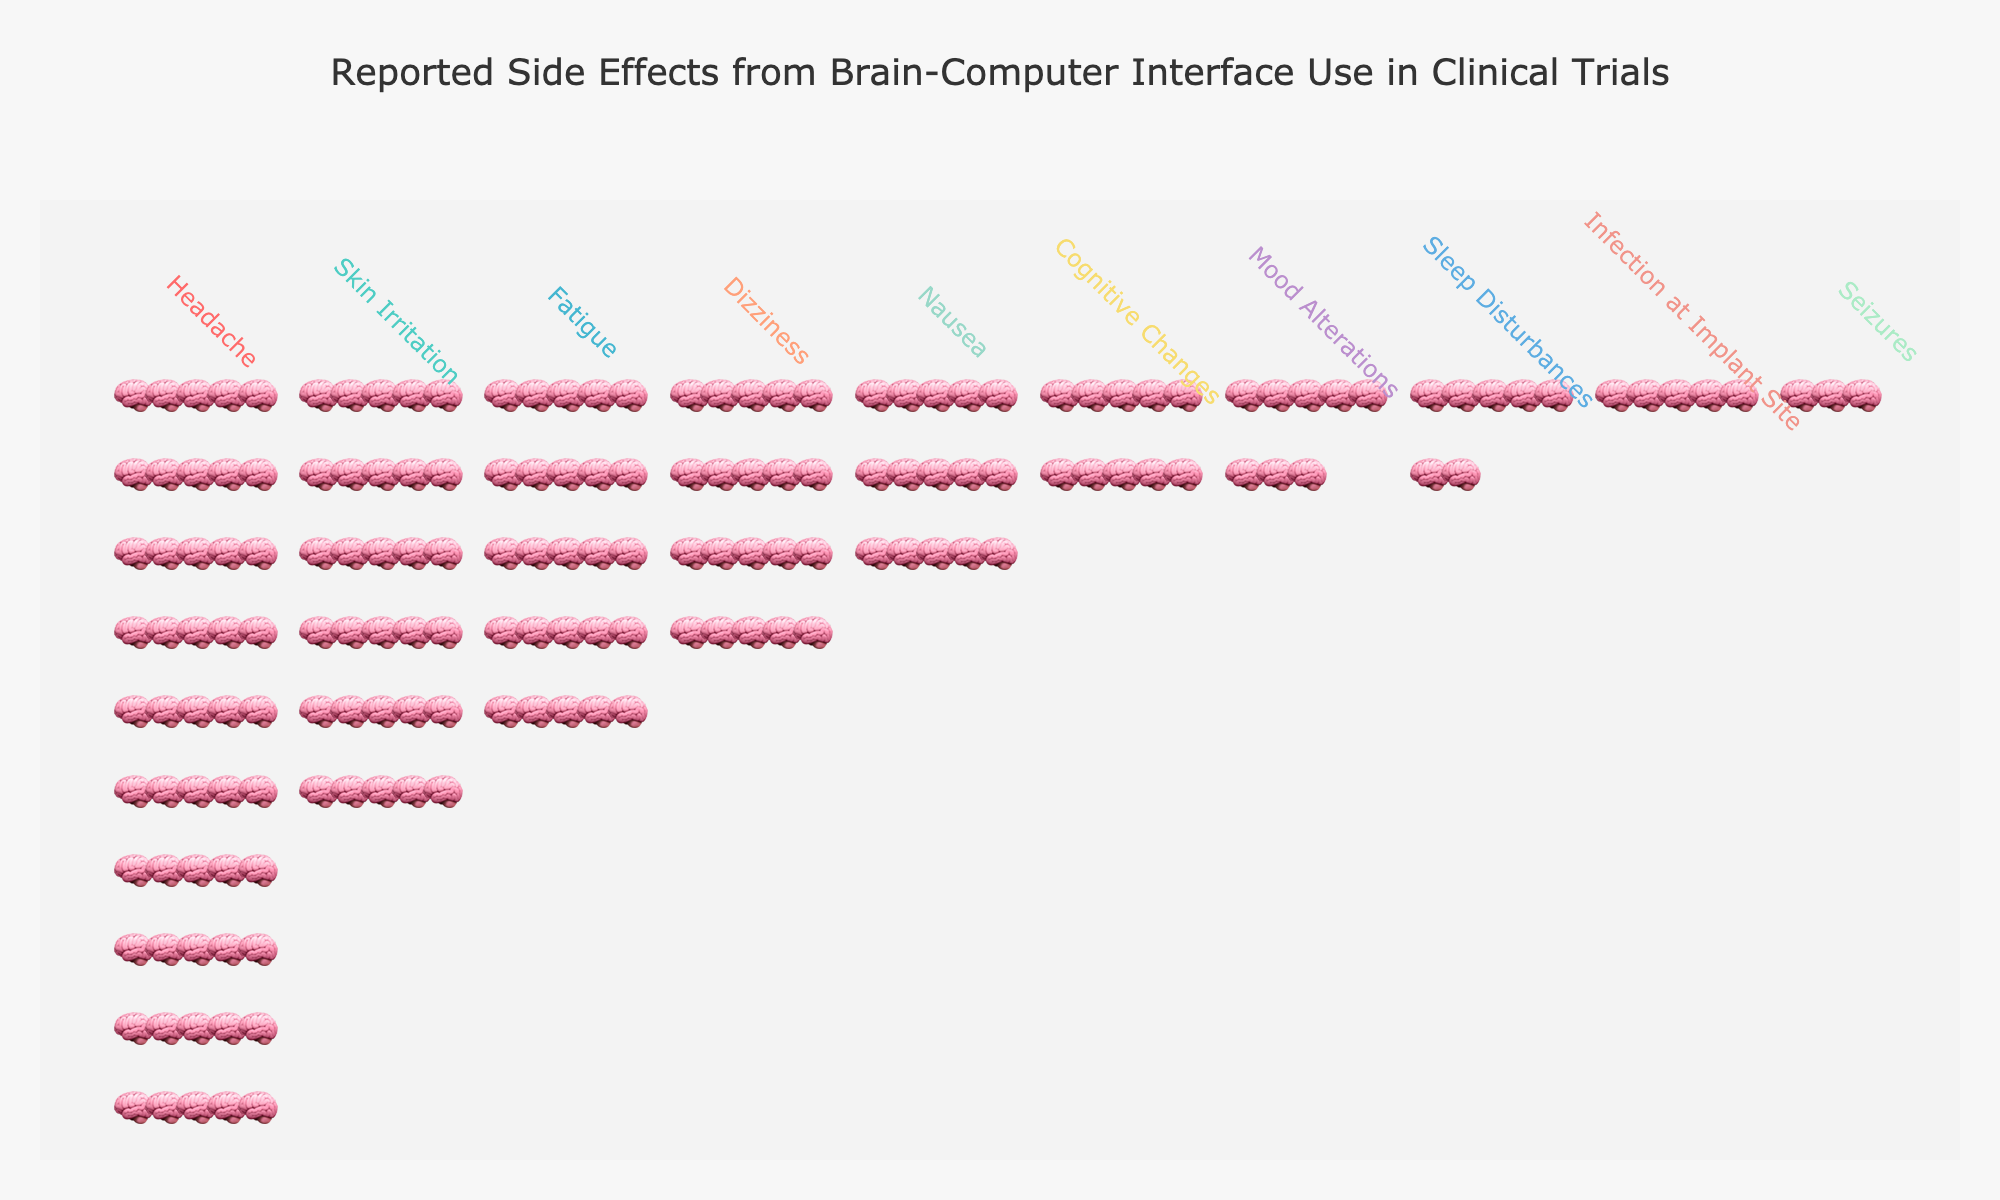What is the title of the plot? The title is usually placed at the top of the plot to describe the main subject or purpose of the figure. Here, it is prominently displayed at the top center.
Answer: Reported Side Effects from Brain-Computer Interface Use in Clinical Trials Which side effect has the most occurrences? The most occurrences are seen in the side effect with the tallest stack of icons.
Answer: Headache Which side effect has the fewest occurrences? The side effect with the shortest stack of icons represents the fewest occurrences.
Answer: Seizures How many occurrences of dizziness are reported? By counting the icons in the stack labeled "Dizziness" or checking the hover information, we get the total occurrences.
Answer: 20 What is the total number of reported side effects? To get this, sum all the occurrences of each side effect. (50 + 30 + 25 + 20 + 15 + 10 + 8 + 7 + 5 + 3)
Answer: 173 Are there more occurrences of fatigue or dizziness? Compare the height of the stacks for "Fatigue" and "Dizziness".
Answer: Fatigue What is the difference in occurrences between skin irritation and infection at implant site? Subtract the occurrences of infection at implant site from those of skin irritation. (30 - 5)
Answer: 25 Which two side effects have the closest number of occurrences? By visually comparing the heights of the stacks, identify the two that appear most similar.
Answer: Mood Alterations and Sleep Disturbances What percentage of the total reported side effects does nausea represent? Calculate this by dividing the occurrences of nausea by the total number of occurrences and multiplying by 100. (15 / 173) * 100
Answer: Approximately 8.67% If the occurrences of seizures doubled, would it still have the fewest occurrences? Doubling the current occurrences of seizures (3 * 2 = 6), compare this with other side effect occurrences.
Answer: No 